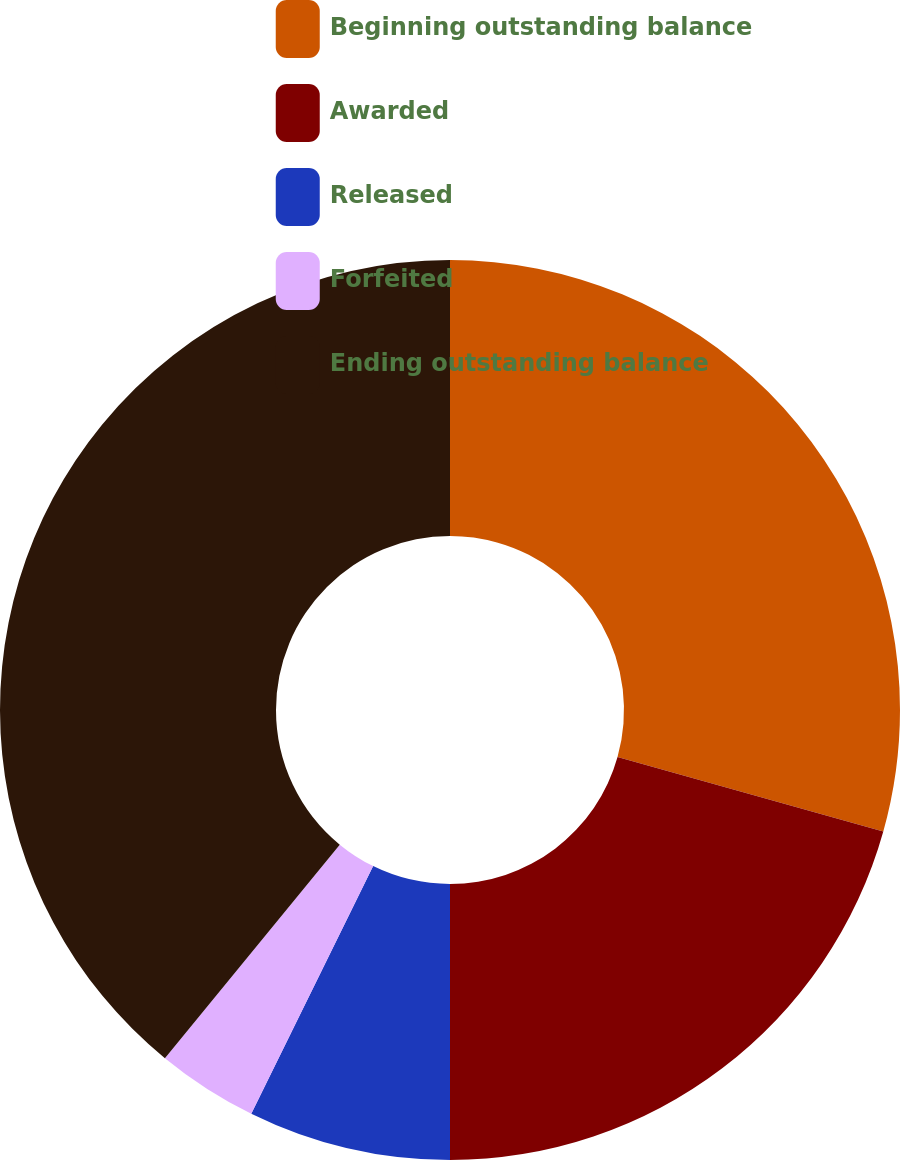Convert chart. <chart><loc_0><loc_0><loc_500><loc_500><pie_chart><fcel>Beginning outstanding balance<fcel>Awarded<fcel>Released<fcel>Forfeited<fcel>Ending outstanding balance<nl><fcel>29.35%<fcel>20.65%<fcel>7.28%<fcel>3.64%<fcel>39.08%<nl></chart> 